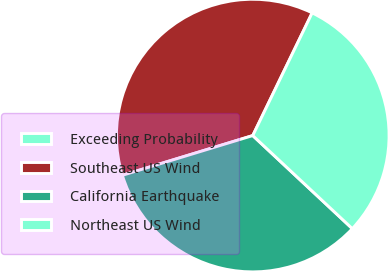Convert chart. <chart><loc_0><loc_0><loc_500><loc_500><pie_chart><fcel>Exceeding Probability<fcel>Southeast US Wind<fcel>California Earthquake<fcel>Northeast US Wind<nl><fcel>0.0%<fcel>36.88%<fcel>33.33%<fcel>29.79%<nl></chart> 